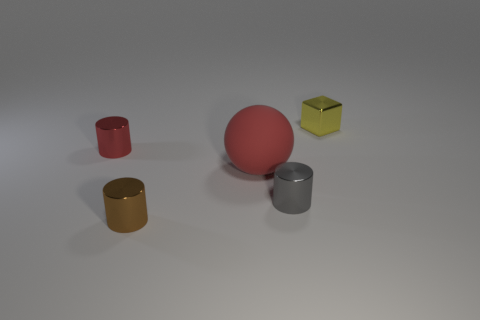What shape is the tiny metallic thing that is the same color as the big rubber object?
Offer a very short reply. Cylinder. How many large balls are there?
Offer a terse response. 1. There is a red metal thing; what shape is it?
Give a very brief answer. Cylinder. How many cyan blocks have the same size as the red shiny object?
Offer a very short reply. 0. Does the small red thing have the same shape as the small brown metallic thing?
Offer a terse response. Yes. What color is the tiny cylinder behind the large matte thing that is on the right side of the tiny brown shiny thing?
Your response must be concise. Red. What is the size of the object that is to the left of the red rubber ball and in front of the tiny red cylinder?
Offer a very short reply. Small. Are there any other things that have the same color as the tiny block?
Ensure brevity in your answer.  No. The tiny brown object that is made of the same material as the red cylinder is what shape?
Offer a terse response. Cylinder. There is a brown thing; is its shape the same as the tiny metal object that is left of the brown shiny cylinder?
Your response must be concise. Yes. 